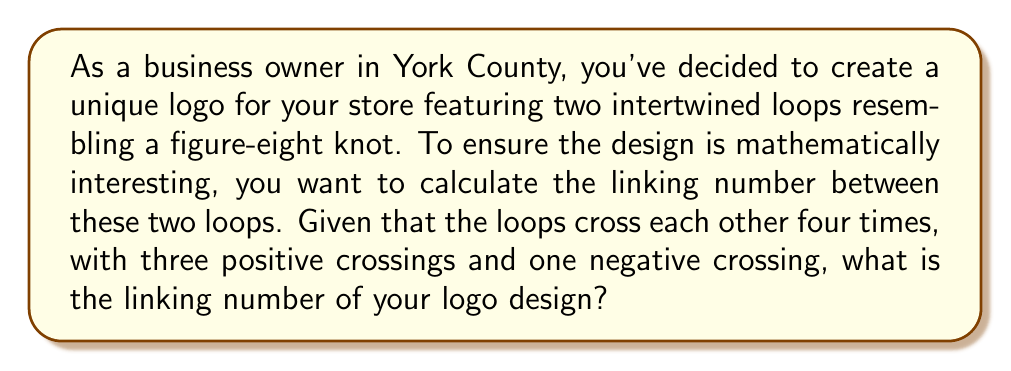Can you answer this question? To calculate the linking number between two intertwined loops, we follow these steps:

1. Identify the number of crossings:
   In this case, there are 4 crossings in total.

2. Determine the sign of each crossing:
   - 3 positive crossings
   - 1 negative crossing

3. Apply the linking number formula:
   $$\text{Linking Number} = \frac{1}{2} \sum_{i=1}^{n} \epsilon_i$$
   Where $n$ is the total number of crossings, and $\epsilon_i$ is the sign of each crossing (+1 for positive, -1 for negative).

4. Substitute the values:
   $$\text{Linking Number} = \frac{1}{2} [(+1) + (+1) + (+1) + (-1)]$$

5. Calculate:
   $$\text{Linking Number} = \frac{1}{2} [3 - 1] = \frac{1}{2} [2] = 1$$

Therefore, the linking number of your logo design is 1.
Answer: 1 